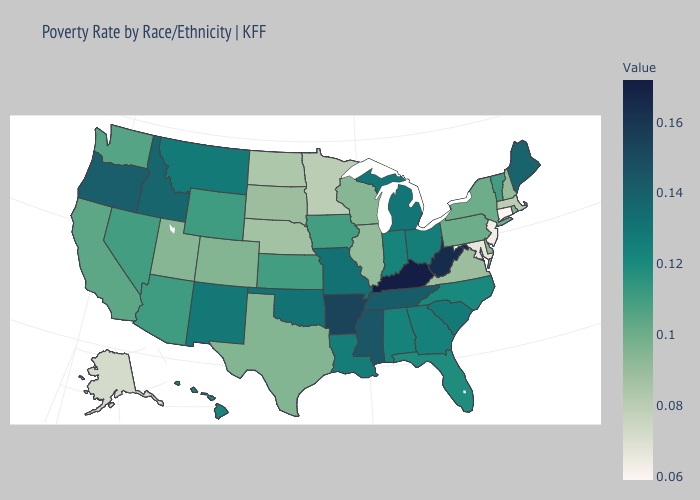Does Connecticut have the lowest value in the USA?
Give a very brief answer. Yes. Among the states that border Illinois , which have the lowest value?
Write a very short answer. Wisconsin. Among the states that border Alabama , does Mississippi have the highest value?
Write a very short answer. Yes. Among the states that border Florida , does Alabama have the highest value?
Be succinct. No. Among the states that border Montana , which have the highest value?
Answer briefly. Idaho. Does Wyoming have a lower value than Kentucky?
Concise answer only. Yes. 